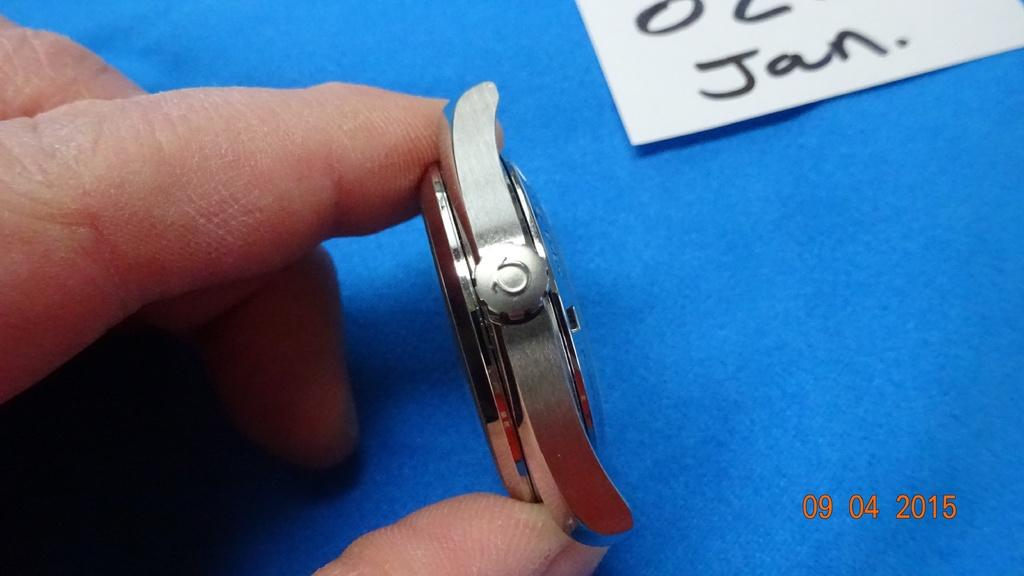<image>
Create a compact narrative representing the image presented. A photo of a watch with the date 09/04/2015 